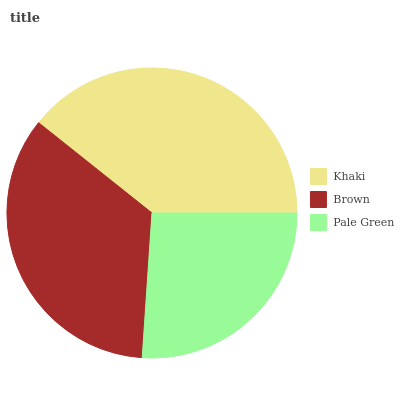Is Pale Green the minimum?
Answer yes or no. Yes. Is Khaki the maximum?
Answer yes or no. Yes. Is Brown the minimum?
Answer yes or no. No. Is Brown the maximum?
Answer yes or no. No. Is Khaki greater than Brown?
Answer yes or no. Yes. Is Brown less than Khaki?
Answer yes or no. Yes. Is Brown greater than Khaki?
Answer yes or no. No. Is Khaki less than Brown?
Answer yes or no. No. Is Brown the high median?
Answer yes or no. Yes. Is Brown the low median?
Answer yes or no. Yes. Is Pale Green the high median?
Answer yes or no. No. Is Khaki the low median?
Answer yes or no. No. 